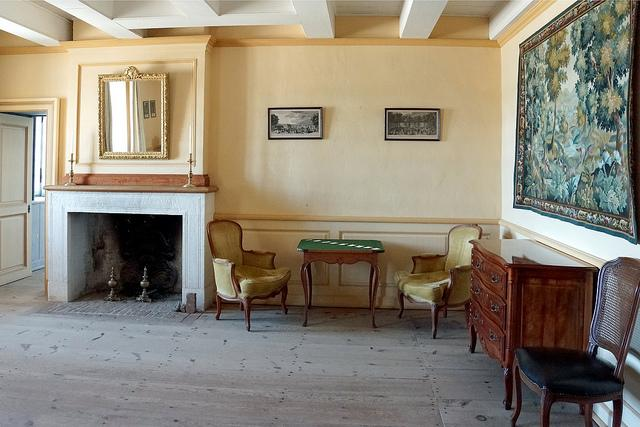Where are the candles placed in the room? Please explain your reasoning. mantle. The candles are placed on a ledge directly above a fireplace. 